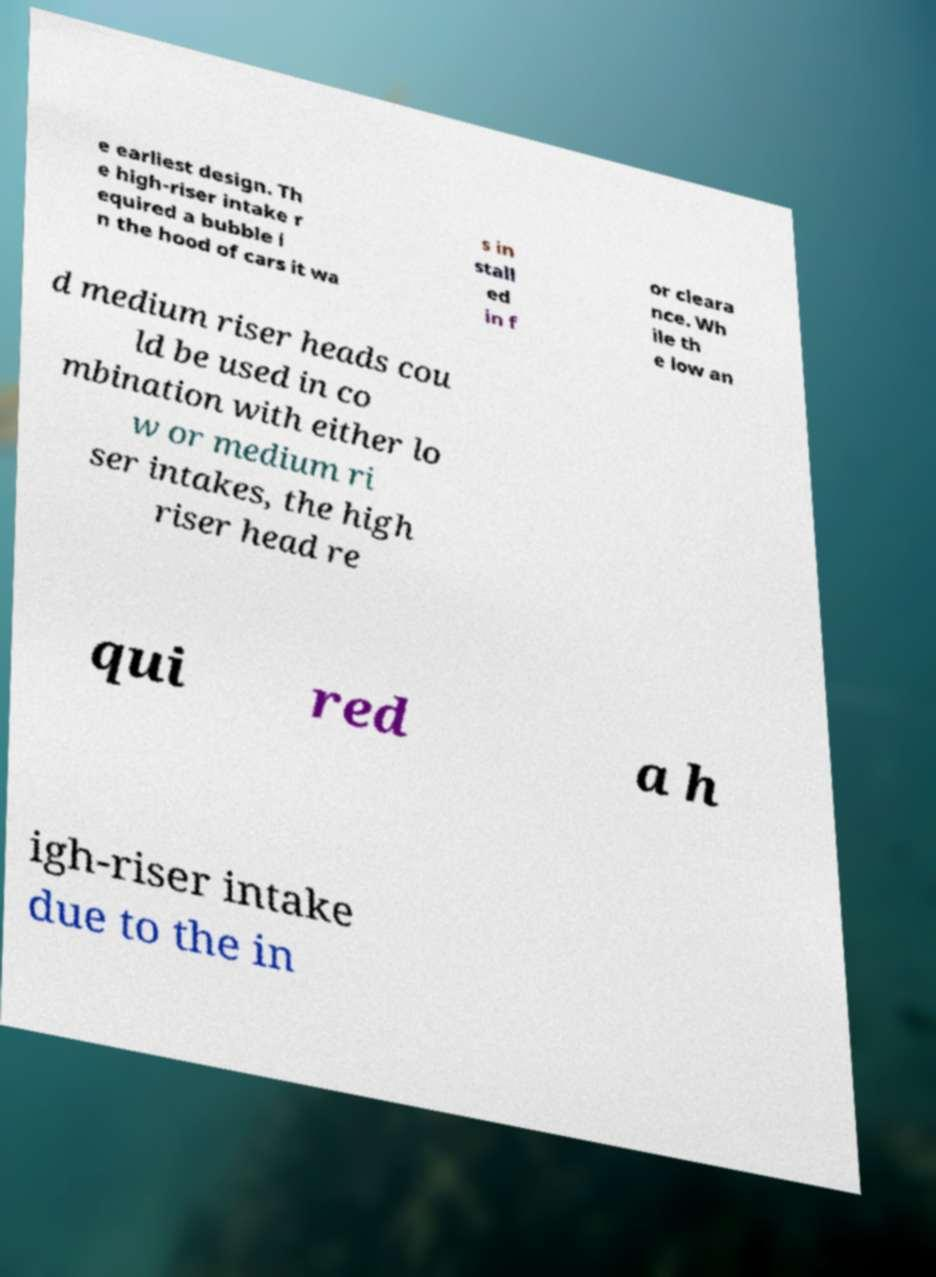There's text embedded in this image that I need extracted. Can you transcribe it verbatim? e earliest design. Th e high-riser intake r equired a bubble i n the hood of cars it wa s in stall ed in f or cleara nce. Wh ile th e low an d medium riser heads cou ld be used in co mbination with either lo w or medium ri ser intakes, the high riser head re qui red a h igh-riser intake due to the in 